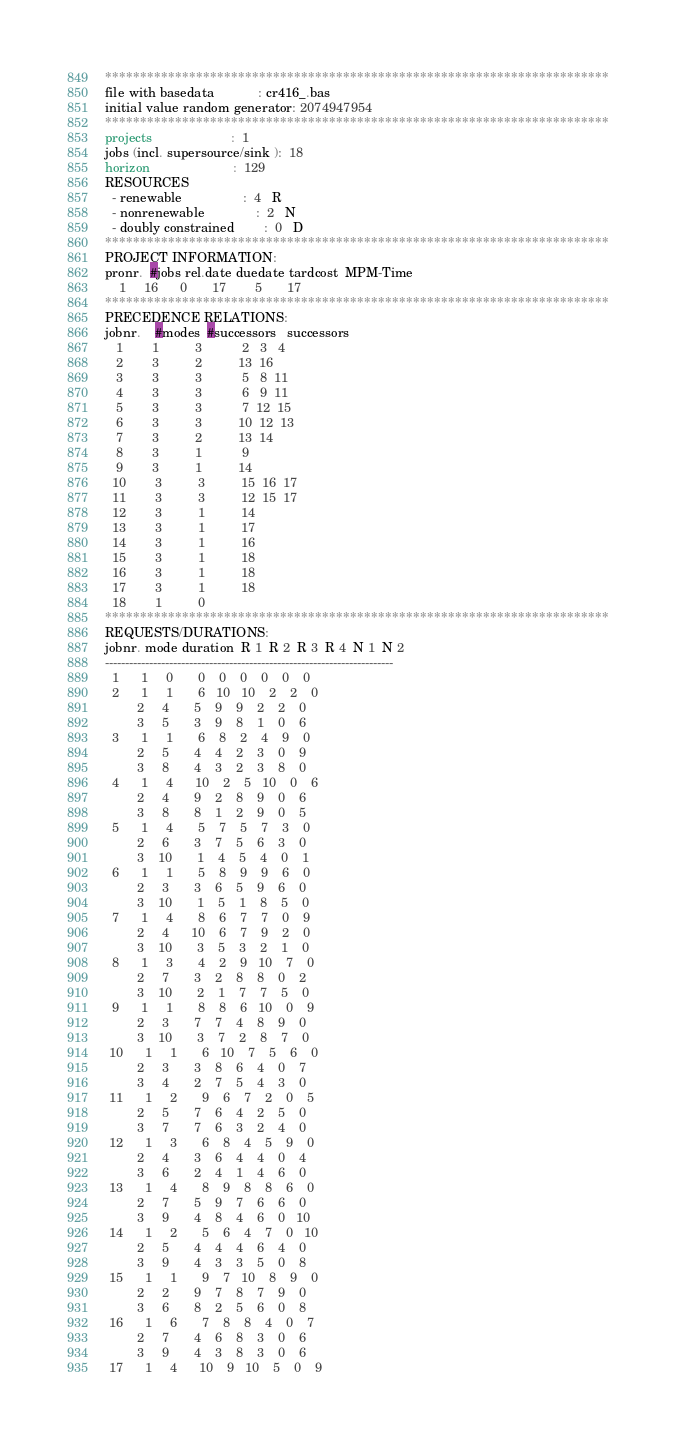Convert code to text. <code><loc_0><loc_0><loc_500><loc_500><_ObjectiveC_>************************************************************************
file with basedata            : cr416_.bas
initial value random generator: 2074947954
************************************************************************
projects                      :  1
jobs (incl. supersource/sink ):  18
horizon                       :  129
RESOURCES
  - renewable                 :  4   R
  - nonrenewable              :  2   N
  - doubly constrained        :  0   D
************************************************************************
PROJECT INFORMATION:
pronr.  #jobs rel.date duedate tardcost  MPM-Time
    1     16      0       17        5       17
************************************************************************
PRECEDENCE RELATIONS:
jobnr.    #modes  #successors   successors
   1        1          3           2   3   4
   2        3          2          13  16
   3        3          3           5   8  11
   4        3          3           6   9  11
   5        3          3           7  12  15
   6        3          3          10  12  13
   7        3          2          13  14
   8        3          1           9
   9        3          1          14
  10        3          3          15  16  17
  11        3          3          12  15  17
  12        3          1          14
  13        3          1          17
  14        3          1          16
  15        3          1          18
  16        3          1          18
  17        3          1          18
  18        1          0        
************************************************************************
REQUESTS/DURATIONS:
jobnr. mode duration  R 1  R 2  R 3  R 4  N 1  N 2
------------------------------------------------------------------------
  1      1     0       0    0    0    0    0    0
  2      1     1       6   10   10    2    2    0
         2     4       5    9    9    2    2    0
         3     5       3    9    8    1    0    6
  3      1     1       6    8    2    4    9    0
         2     5       4    4    2    3    0    9
         3     8       4    3    2    3    8    0
  4      1     4      10    2    5   10    0    6
         2     4       9    2    8    9    0    6
         3     8       8    1    2    9    0    5
  5      1     4       5    7    5    7    3    0
         2     6       3    7    5    6    3    0
         3    10       1    4    5    4    0    1
  6      1     1       5    8    9    9    6    0
         2     3       3    6    5    9    6    0
         3    10       1    5    1    8    5    0
  7      1     4       8    6    7    7    0    9
         2     4      10    6    7    9    2    0
         3    10       3    5    3    2    1    0
  8      1     3       4    2    9   10    7    0
         2     7       3    2    8    8    0    2
         3    10       2    1    7    7    5    0
  9      1     1       8    8    6   10    0    9
         2     3       7    7    4    8    9    0
         3    10       3    7    2    8    7    0
 10      1     1       6   10    7    5    6    0
         2     3       3    8    6    4    0    7
         3     4       2    7    5    4    3    0
 11      1     2       9    6    7    2    0    5
         2     5       7    6    4    2    5    0
         3     7       7    6    3    2    4    0
 12      1     3       6    8    4    5    9    0
         2     4       3    6    4    4    0    4
         3     6       2    4    1    4    6    0
 13      1     4       8    9    8    8    6    0
         2     7       5    9    7    6    6    0
         3     9       4    8    4    6    0   10
 14      1     2       5    6    4    7    0   10
         2     5       4    4    4    6    4    0
         3     9       4    3    3    5    0    8
 15      1     1       9    7   10    8    9    0
         2     2       9    7    8    7    9    0
         3     6       8    2    5    6    0    8
 16      1     6       7    8    8    4    0    7
         2     7       4    6    8    3    0    6
         3     9       4    3    8    3    0    6
 17      1     4      10    9   10    5    0    9</code> 